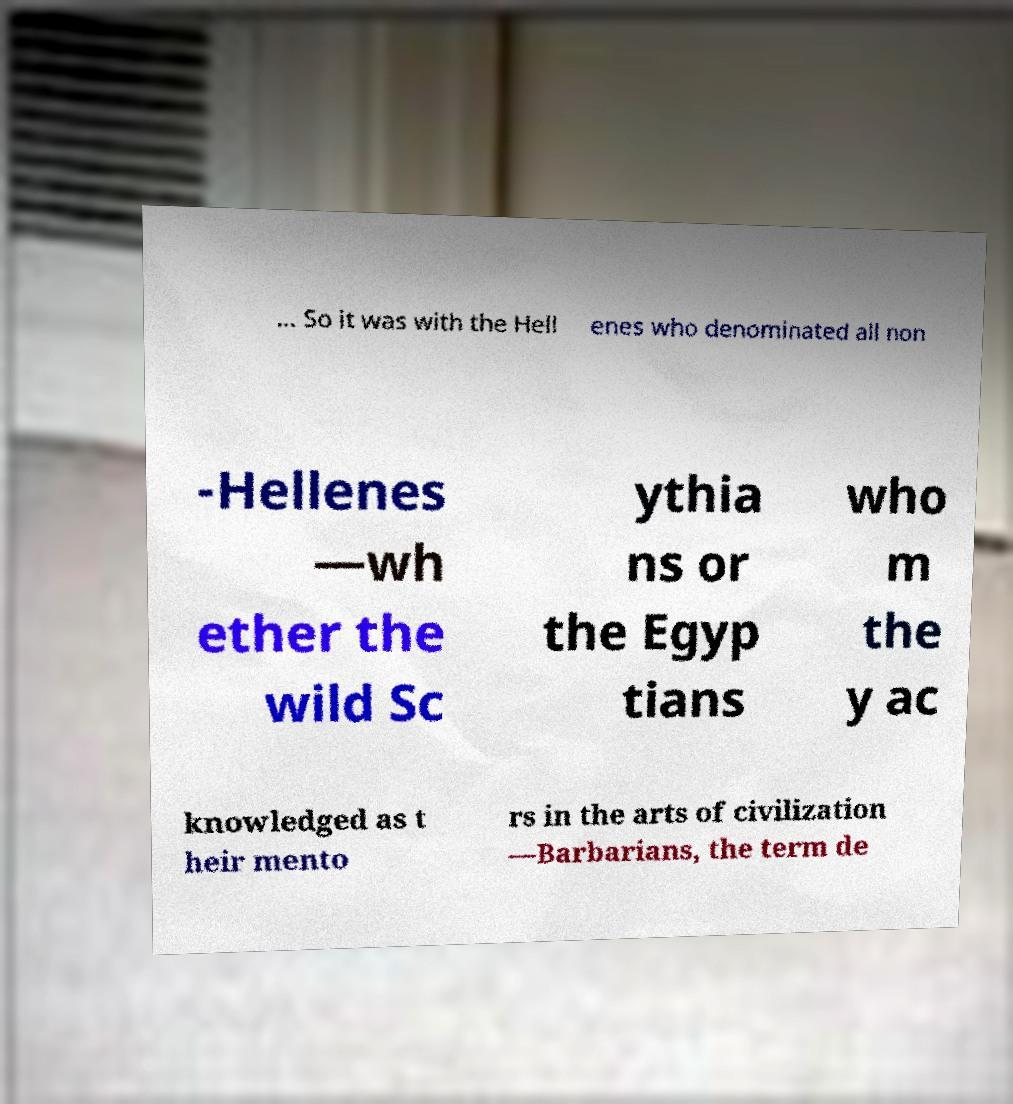Please read and relay the text visible in this image. What does it say? ... So it was with the Hell enes who denominated all non -Hellenes —wh ether the wild Sc ythia ns or the Egyp tians who m the y ac knowledged as t heir mento rs in the arts of civilization —Barbarians, the term de 